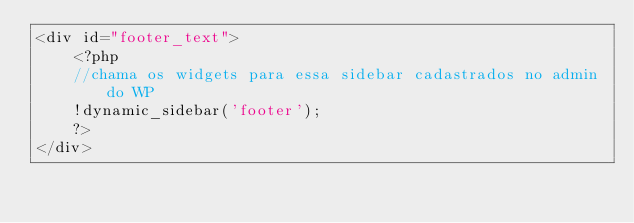<code> <loc_0><loc_0><loc_500><loc_500><_PHP_><div id="footer_text">
    <?php
    //chama os widgets para essa sidebar cadastrados no admin do WP 
    !dynamic_sidebar('footer');
    ?>
</div></code> 